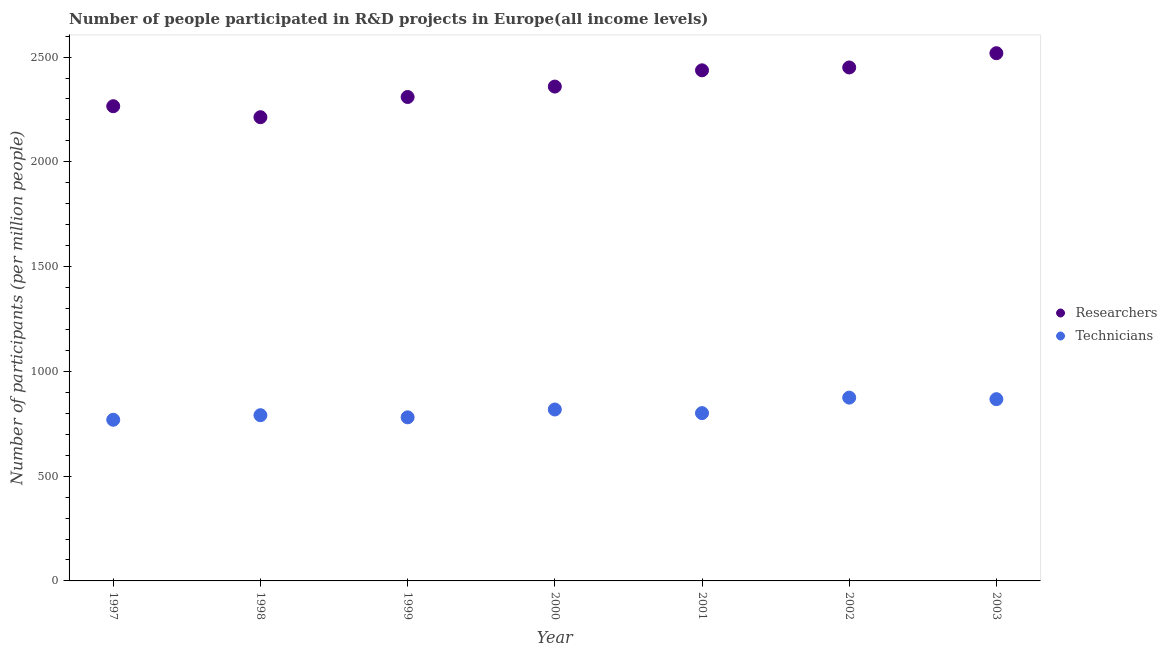What is the number of technicians in 1999?
Your answer should be very brief. 780.67. Across all years, what is the maximum number of researchers?
Provide a short and direct response. 2518.44. Across all years, what is the minimum number of technicians?
Ensure brevity in your answer.  769.04. What is the total number of researchers in the graph?
Provide a succinct answer. 1.66e+04. What is the difference between the number of technicians in 2000 and that in 2003?
Your response must be concise. -49.28. What is the difference between the number of researchers in 2001 and the number of technicians in 2002?
Give a very brief answer. 1561.99. What is the average number of researchers per year?
Provide a succinct answer. 2364.67. In the year 1998, what is the difference between the number of technicians and number of researchers?
Your answer should be very brief. -1422.15. In how many years, is the number of researchers greater than 1200?
Your answer should be very brief. 7. What is the ratio of the number of technicians in 2000 to that in 2001?
Your answer should be very brief. 1.02. Is the number of researchers in 2000 less than that in 2003?
Your answer should be very brief. Yes. Is the difference between the number of researchers in 2001 and 2002 greater than the difference between the number of technicians in 2001 and 2002?
Make the answer very short. Yes. What is the difference between the highest and the second highest number of researchers?
Offer a very short reply. 68.08. What is the difference between the highest and the lowest number of technicians?
Provide a short and direct response. 105.73. In how many years, is the number of technicians greater than the average number of technicians taken over all years?
Make the answer very short. 3. Is the sum of the number of researchers in 2000 and 2003 greater than the maximum number of technicians across all years?
Your response must be concise. Yes. Is the number of researchers strictly less than the number of technicians over the years?
Provide a short and direct response. No. How many dotlines are there?
Give a very brief answer. 2. How many years are there in the graph?
Provide a short and direct response. 7. How are the legend labels stacked?
Your answer should be very brief. Vertical. What is the title of the graph?
Your answer should be very brief. Number of people participated in R&D projects in Europe(all income levels). What is the label or title of the Y-axis?
Provide a succinct answer. Number of participants (per million people). What is the Number of participants (per million people) in Researchers in 1997?
Offer a very short reply. 2265.42. What is the Number of participants (per million people) in Technicians in 1997?
Provide a succinct answer. 769.04. What is the Number of participants (per million people) in Researchers in 1998?
Your answer should be very brief. 2213.05. What is the Number of participants (per million people) of Technicians in 1998?
Give a very brief answer. 790.9. What is the Number of participants (per million people) of Researchers in 1999?
Your answer should be very brief. 2309.44. What is the Number of participants (per million people) in Technicians in 1999?
Your answer should be very brief. 780.67. What is the Number of participants (per million people) of Researchers in 2000?
Keep it short and to the point. 2359.22. What is the Number of participants (per million people) of Technicians in 2000?
Give a very brief answer. 818.09. What is the Number of participants (per million people) in Researchers in 2001?
Your answer should be very brief. 2436.76. What is the Number of participants (per million people) of Technicians in 2001?
Your answer should be compact. 800.78. What is the Number of participants (per million people) in Researchers in 2002?
Your answer should be very brief. 2450.36. What is the Number of participants (per million people) of Technicians in 2002?
Offer a terse response. 874.77. What is the Number of participants (per million people) in Researchers in 2003?
Give a very brief answer. 2518.44. What is the Number of participants (per million people) of Technicians in 2003?
Offer a very short reply. 867.37. Across all years, what is the maximum Number of participants (per million people) of Researchers?
Your response must be concise. 2518.44. Across all years, what is the maximum Number of participants (per million people) of Technicians?
Your response must be concise. 874.77. Across all years, what is the minimum Number of participants (per million people) of Researchers?
Offer a terse response. 2213.05. Across all years, what is the minimum Number of participants (per million people) in Technicians?
Provide a succinct answer. 769.04. What is the total Number of participants (per million people) in Researchers in the graph?
Make the answer very short. 1.66e+04. What is the total Number of participants (per million people) of Technicians in the graph?
Offer a terse response. 5701.63. What is the difference between the Number of participants (per million people) in Researchers in 1997 and that in 1998?
Keep it short and to the point. 52.37. What is the difference between the Number of participants (per million people) of Technicians in 1997 and that in 1998?
Your answer should be very brief. -21.86. What is the difference between the Number of participants (per million people) in Researchers in 1997 and that in 1999?
Offer a very short reply. -44.02. What is the difference between the Number of participants (per million people) in Technicians in 1997 and that in 1999?
Offer a very short reply. -11.63. What is the difference between the Number of participants (per million people) in Researchers in 1997 and that in 2000?
Ensure brevity in your answer.  -93.8. What is the difference between the Number of participants (per million people) in Technicians in 1997 and that in 2000?
Your response must be concise. -49.05. What is the difference between the Number of participants (per million people) in Researchers in 1997 and that in 2001?
Provide a succinct answer. -171.34. What is the difference between the Number of participants (per million people) of Technicians in 1997 and that in 2001?
Your answer should be very brief. -31.74. What is the difference between the Number of participants (per million people) of Researchers in 1997 and that in 2002?
Keep it short and to the point. -184.94. What is the difference between the Number of participants (per million people) in Technicians in 1997 and that in 2002?
Provide a succinct answer. -105.73. What is the difference between the Number of participants (per million people) in Researchers in 1997 and that in 2003?
Keep it short and to the point. -253.01. What is the difference between the Number of participants (per million people) in Technicians in 1997 and that in 2003?
Offer a terse response. -98.34. What is the difference between the Number of participants (per million people) of Researchers in 1998 and that in 1999?
Offer a terse response. -96.39. What is the difference between the Number of participants (per million people) of Technicians in 1998 and that in 1999?
Ensure brevity in your answer.  10.23. What is the difference between the Number of participants (per million people) in Researchers in 1998 and that in 2000?
Keep it short and to the point. -146.17. What is the difference between the Number of participants (per million people) of Technicians in 1998 and that in 2000?
Keep it short and to the point. -27.19. What is the difference between the Number of participants (per million people) in Researchers in 1998 and that in 2001?
Offer a very short reply. -223.71. What is the difference between the Number of participants (per million people) of Technicians in 1998 and that in 2001?
Give a very brief answer. -9.87. What is the difference between the Number of participants (per million people) of Researchers in 1998 and that in 2002?
Your answer should be compact. -237.31. What is the difference between the Number of participants (per million people) of Technicians in 1998 and that in 2002?
Make the answer very short. -83.87. What is the difference between the Number of participants (per million people) of Researchers in 1998 and that in 2003?
Offer a terse response. -305.38. What is the difference between the Number of participants (per million people) of Technicians in 1998 and that in 2003?
Give a very brief answer. -76.47. What is the difference between the Number of participants (per million people) in Researchers in 1999 and that in 2000?
Offer a very short reply. -49.78. What is the difference between the Number of participants (per million people) in Technicians in 1999 and that in 2000?
Ensure brevity in your answer.  -37.42. What is the difference between the Number of participants (per million people) in Researchers in 1999 and that in 2001?
Offer a terse response. -127.32. What is the difference between the Number of participants (per million people) in Technicians in 1999 and that in 2001?
Your answer should be compact. -20.1. What is the difference between the Number of participants (per million people) of Researchers in 1999 and that in 2002?
Give a very brief answer. -140.92. What is the difference between the Number of participants (per million people) of Technicians in 1999 and that in 2002?
Keep it short and to the point. -94.09. What is the difference between the Number of participants (per million people) of Researchers in 1999 and that in 2003?
Ensure brevity in your answer.  -208.99. What is the difference between the Number of participants (per million people) in Technicians in 1999 and that in 2003?
Offer a terse response. -86.7. What is the difference between the Number of participants (per million people) in Researchers in 2000 and that in 2001?
Your answer should be compact. -77.54. What is the difference between the Number of participants (per million people) in Technicians in 2000 and that in 2001?
Give a very brief answer. 17.32. What is the difference between the Number of participants (per million people) of Researchers in 2000 and that in 2002?
Your response must be concise. -91.14. What is the difference between the Number of participants (per million people) of Technicians in 2000 and that in 2002?
Provide a short and direct response. -56.67. What is the difference between the Number of participants (per million people) of Researchers in 2000 and that in 2003?
Offer a very short reply. -159.21. What is the difference between the Number of participants (per million people) of Technicians in 2000 and that in 2003?
Ensure brevity in your answer.  -49.28. What is the difference between the Number of participants (per million people) in Researchers in 2001 and that in 2002?
Provide a short and direct response. -13.6. What is the difference between the Number of participants (per million people) of Technicians in 2001 and that in 2002?
Offer a very short reply. -73.99. What is the difference between the Number of participants (per million people) of Researchers in 2001 and that in 2003?
Give a very brief answer. -81.67. What is the difference between the Number of participants (per million people) in Technicians in 2001 and that in 2003?
Make the answer very short. -66.6. What is the difference between the Number of participants (per million people) of Researchers in 2002 and that in 2003?
Your answer should be compact. -68.08. What is the difference between the Number of participants (per million people) in Technicians in 2002 and that in 2003?
Your answer should be very brief. 7.39. What is the difference between the Number of participants (per million people) in Researchers in 1997 and the Number of participants (per million people) in Technicians in 1998?
Offer a terse response. 1474.52. What is the difference between the Number of participants (per million people) of Researchers in 1997 and the Number of participants (per million people) of Technicians in 1999?
Your answer should be compact. 1484.75. What is the difference between the Number of participants (per million people) in Researchers in 1997 and the Number of participants (per million people) in Technicians in 2000?
Make the answer very short. 1447.33. What is the difference between the Number of participants (per million people) in Researchers in 1997 and the Number of participants (per million people) in Technicians in 2001?
Your answer should be very brief. 1464.65. What is the difference between the Number of participants (per million people) of Researchers in 1997 and the Number of participants (per million people) of Technicians in 2002?
Offer a very short reply. 1390.66. What is the difference between the Number of participants (per million people) in Researchers in 1997 and the Number of participants (per million people) in Technicians in 2003?
Provide a short and direct response. 1398.05. What is the difference between the Number of participants (per million people) of Researchers in 1998 and the Number of participants (per million people) of Technicians in 1999?
Your response must be concise. 1432.38. What is the difference between the Number of participants (per million people) of Researchers in 1998 and the Number of participants (per million people) of Technicians in 2000?
Your response must be concise. 1394.96. What is the difference between the Number of participants (per million people) of Researchers in 1998 and the Number of participants (per million people) of Technicians in 2001?
Ensure brevity in your answer.  1412.28. What is the difference between the Number of participants (per million people) of Researchers in 1998 and the Number of participants (per million people) of Technicians in 2002?
Keep it short and to the point. 1338.29. What is the difference between the Number of participants (per million people) in Researchers in 1998 and the Number of participants (per million people) in Technicians in 2003?
Your response must be concise. 1345.68. What is the difference between the Number of participants (per million people) in Researchers in 1999 and the Number of participants (per million people) in Technicians in 2000?
Your answer should be compact. 1491.35. What is the difference between the Number of participants (per million people) in Researchers in 1999 and the Number of participants (per million people) in Technicians in 2001?
Give a very brief answer. 1508.67. What is the difference between the Number of participants (per million people) in Researchers in 1999 and the Number of participants (per million people) in Technicians in 2002?
Provide a succinct answer. 1434.68. What is the difference between the Number of participants (per million people) of Researchers in 1999 and the Number of participants (per million people) of Technicians in 2003?
Provide a short and direct response. 1442.07. What is the difference between the Number of participants (per million people) in Researchers in 2000 and the Number of participants (per million people) in Technicians in 2001?
Your response must be concise. 1558.45. What is the difference between the Number of participants (per million people) in Researchers in 2000 and the Number of participants (per million people) in Technicians in 2002?
Provide a short and direct response. 1484.45. What is the difference between the Number of participants (per million people) in Researchers in 2000 and the Number of participants (per million people) in Technicians in 2003?
Ensure brevity in your answer.  1491.85. What is the difference between the Number of participants (per million people) of Researchers in 2001 and the Number of participants (per million people) of Technicians in 2002?
Provide a succinct answer. 1561.99. What is the difference between the Number of participants (per million people) in Researchers in 2001 and the Number of participants (per million people) in Technicians in 2003?
Give a very brief answer. 1569.39. What is the difference between the Number of participants (per million people) of Researchers in 2002 and the Number of participants (per million people) of Technicians in 2003?
Keep it short and to the point. 1582.99. What is the average Number of participants (per million people) of Researchers per year?
Offer a very short reply. 2364.67. What is the average Number of participants (per million people) in Technicians per year?
Keep it short and to the point. 814.52. In the year 1997, what is the difference between the Number of participants (per million people) in Researchers and Number of participants (per million people) in Technicians?
Give a very brief answer. 1496.38. In the year 1998, what is the difference between the Number of participants (per million people) of Researchers and Number of participants (per million people) of Technicians?
Give a very brief answer. 1422.15. In the year 1999, what is the difference between the Number of participants (per million people) of Researchers and Number of participants (per million people) of Technicians?
Offer a very short reply. 1528.77. In the year 2000, what is the difference between the Number of participants (per million people) in Researchers and Number of participants (per million people) in Technicians?
Your response must be concise. 1541.13. In the year 2001, what is the difference between the Number of participants (per million people) in Researchers and Number of participants (per million people) in Technicians?
Offer a very short reply. 1635.99. In the year 2002, what is the difference between the Number of participants (per million people) in Researchers and Number of participants (per million people) in Technicians?
Ensure brevity in your answer.  1575.59. In the year 2003, what is the difference between the Number of participants (per million people) of Researchers and Number of participants (per million people) of Technicians?
Ensure brevity in your answer.  1651.06. What is the ratio of the Number of participants (per million people) in Researchers in 1997 to that in 1998?
Your response must be concise. 1.02. What is the ratio of the Number of participants (per million people) of Technicians in 1997 to that in 1998?
Your answer should be very brief. 0.97. What is the ratio of the Number of participants (per million people) in Researchers in 1997 to that in 1999?
Ensure brevity in your answer.  0.98. What is the ratio of the Number of participants (per million people) in Technicians in 1997 to that in 1999?
Offer a very short reply. 0.99. What is the ratio of the Number of participants (per million people) in Researchers in 1997 to that in 2000?
Offer a terse response. 0.96. What is the ratio of the Number of participants (per million people) of Technicians in 1997 to that in 2000?
Offer a very short reply. 0.94. What is the ratio of the Number of participants (per million people) in Researchers in 1997 to that in 2001?
Your answer should be compact. 0.93. What is the ratio of the Number of participants (per million people) of Technicians in 1997 to that in 2001?
Offer a terse response. 0.96. What is the ratio of the Number of participants (per million people) of Researchers in 1997 to that in 2002?
Offer a very short reply. 0.92. What is the ratio of the Number of participants (per million people) of Technicians in 1997 to that in 2002?
Offer a terse response. 0.88. What is the ratio of the Number of participants (per million people) in Researchers in 1997 to that in 2003?
Provide a short and direct response. 0.9. What is the ratio of the Number of participants (per million people) in Technicians in 1997 to that in 2003?
Provide a short and direct response. 0.89. What is the ratio of the Number of participants (per million people) of Researchers in 1998 to that in 1999?
Offer a very short reply. 0.96. What is the ratio of the Number of participants (per million people) of Technicians in 1998 to that in 1999?
Make the answer very short. 1.01. What is the ratio of the Number of participants (per million people) in Researchers in 1998 to that in 2000?
Make the answer very short. 0.94. What is the ratio of the Number of participants (per million people) of Technicians in 1998 to that in 2000?
Give a very brief answer. 0.97. What is the ratio of the Number of participants (per million people) in Researchers in 1998 to that in 2001?
Your answer should be compact. 0.91. What is the ratio of the Number of participants (per million people) of Researchers in 1998 to that in 2002?
Offer a terse response. 0.9. What is the ratio of the Number of participants (per million people) in Technicians in 1998 to that in 2002?
Provide a short and direct response. 0.9. What is the ratio of the Number of participants (per million people) of Researchers in 1998 to that in 2003?
Offer a terse response. 0.88. What is the ratio of the Number of participants (per million people) of Technicians in 1998 to that in 2003?
Give a very brief answer. 0.91. What is the ratio of the Number of participants (per million people) in Researchers in 1999 to that in 2000?
Your response must be concise. 0.98. What is the ratio of the Number of participants (per million people) in Technicians in 1999 to that in 2000?
Offer a terse response. 0.95. What is the ratio of the Number of participants (per million people) in Researchers in 1999 to that in 2001?
Your answer should be compact. 0.95. What is the ratio of the Number of participants (per million people) in Technicians in 1999 to that in 2001?
Your answer should be compact. 0.97. What is the ratio of the Number of participants (per million people) of Researchers in 1999 to that in 2002?
Your answer should be compact. 0.94. What is the ratio of the Number of participants (per million people) of Technicians in 1999 to that in 2002?
Provide a succinct answer. 0.89. What is the ratio of the Number of participants (per million people) in Researchers in 1999 to that in 2003?
Keep it short and to the point. 0.92. What is the ratio of the Number of participants (per million people) of Technicians in 1999 to that in 2003?
Offer a very short reply. 0.9. What is the ratio of the Number of participants (per million people) in Researchers in 2000 to that in 2001?
Your answer should be very brief. 0.97. What is the ratio of the Number of participants (per million people) in Technicians in 2000 to that in 2001?
Your response must be concise. 1.02. What is the ratio of the Number of participants (per million people) in Researchers in 2000 to that in 2002?
Give a very brief answer. 0.96. What is the ratio of the Number of participants (per million people) in Technicians in 2000 to that in 2002?
Your response must be concise. 0.94. What is the ratio of the Number of participants (per million people) of Researchers in 2000 to that in 2003?
Ensure brevity in your answer.  0.94. What is the ratio of the Number of participants (per million people) in Technicians in 2000 to that in 2003?
Make the answer very short. 0.94. What is the ratio of the Number of participants (per million people) of Technicians in 2001 to that in 2002?
Offer a terse response. 0.92. What is the ratio of the Number of participants (per million people) of Researchers in 2001 to that in 2003?
Give a very brief answer. 0.97. What is the ratio of the Number of participants (per million people) of Technicians in 2001 to that in 2003?
Provide a short and direct response. 0.92. What is the ratio of the Number of participants (per million people) in Researchers in 2002 to that in 2003?
Offer a very short reply. 0.97. What is the ratio of the Number of participants (per million people) of Technicians in 2002 to that in 2003?
Your response must be concise. 1.01. What is the difference between the highest and the second highest Number of participants (per million people) of Researchers?
Offer a terse response. 68.08. What is the difference between the highest and the second highest Number of participants (per million people) in Technicians?
Your response must be concise. 7.39. What is the difference between the highest and the lowest Number of participants (per million people) of Researchers?
Give a very brief answer. 305.38. What is the difference between the highest and the lowest Number of participants (per million people) of Technicians?
Provide a short and direct response. 105.73. 